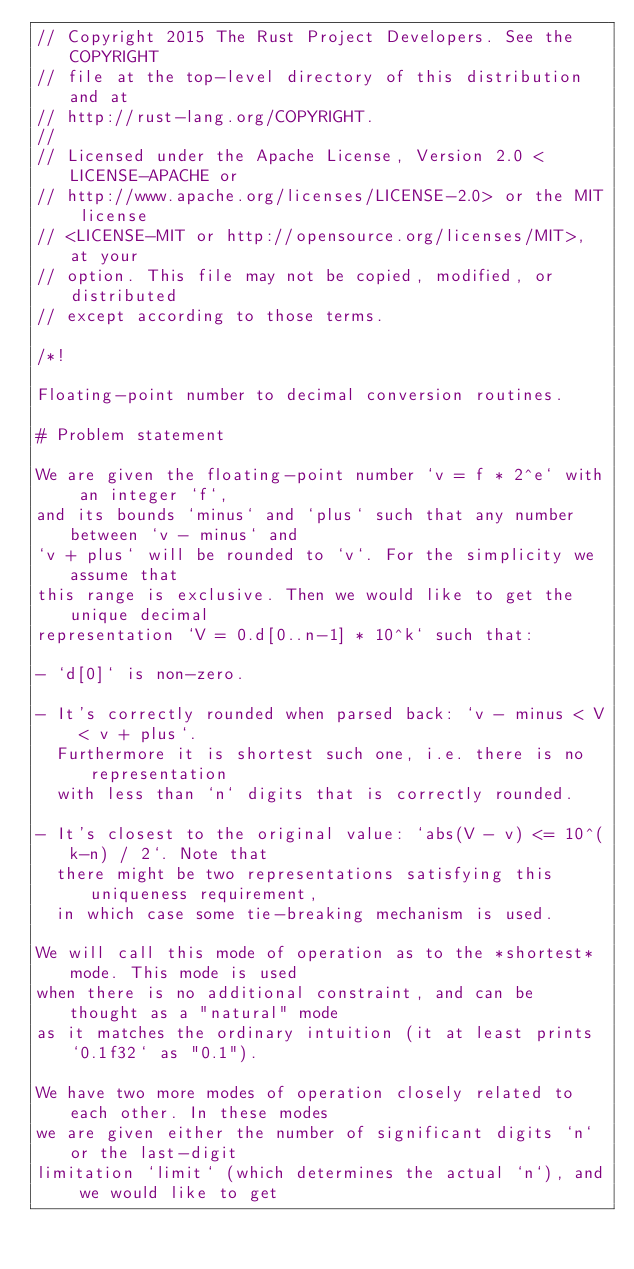Convert code to text. <code><loc_0><loc_0><loc_500><loc_500><_Rust_>// Copyright 2015 The Rust Project Developers. See the COPYRIGHT
// file at the top-level directory of this distribution and at
// http://rust-lang.org/COPYRIGHT.
//
// Licensed under the Apache License, Version 2.0 <LICENSE-APACHE or
// http://www.apache.org/licenses/LICENSE-2.0> or the MIT license
// <LICENSE-MIT or http://opensource.org/licenses/MIT>, at your
// option. This file may not be copied, modified, or distributed
// except according to those terms.

/*!

Floating-point number to decimal conversion routines.

# Problem statement

We are given the floating-point number `v = f * 2^e` with an integer `f`,
and its bounds `minus` and `plus` such that any number between `v - minus` and
`v + plus` will be rounded to `v`. For the simplicity we assume that
this range is exclusive. Then we would like to get the unique decimal
representation `V = 0.d[0..n-1] * 10^k` such that:

- `d[0]` is non-zero.

- It's correctly rounded when parsed back: `v - minus < V < v + plus`.
  Furthermore it is shortest such one, i.e. there is no representation
  with less than `n` digits that is correctly rounded.

- It's closest to the original value: `abs(V - v) <= 10^(k-n) / 2`. Note that
  there might be two representations satisfying this uniqueness requirement,
  in which case some tie-breaking mechanism is used.

We will call this mode of operation as to the *shortest* mode. This mode is used
when there is no additional constraint, and can be thought as a "natural" mode
as it matches the ordinary intuition (it at least prints `0.1f32` as "0.1").

We have two more modes of operation closely related to each other. In these modes
we are given either the number of significant digits `n` or the last-digit
limitation `limit` (which determines the actual `n`), and we would like to get</code> 